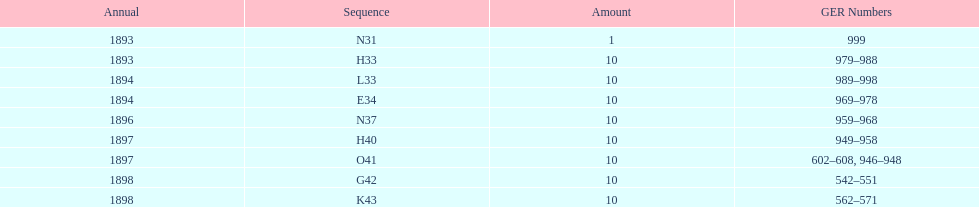What is the total number of locomotives made during this time? 81. 